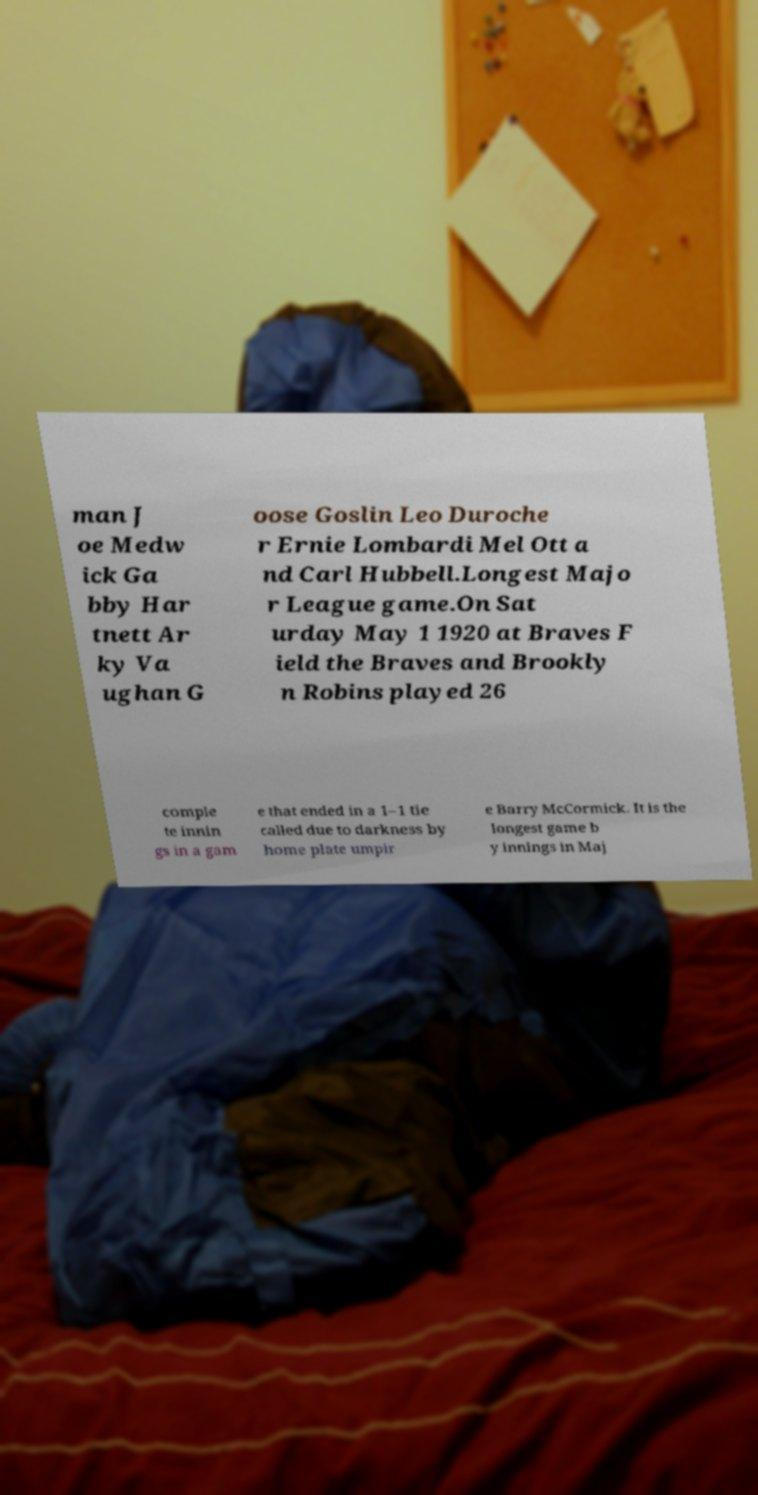Can you accurately transcribe the text from the provided image for me? man J oe Medw ick Ga bby Har tnett Ar ky Va ughan G oose Goslin Leo Duroche r Ernie Lombardi Mel Ott a nd Carl Hubbell.Longest Majo r League game.On Sat urday May 1 1920 at Braves F ield the Braves and Brookly n Robins played 26 comple te innin gs in a gam e that ended in a 1–1 tie called due to darkness by home plate umpir e Barry McCormick. It is the longest game b y innings in Maj 